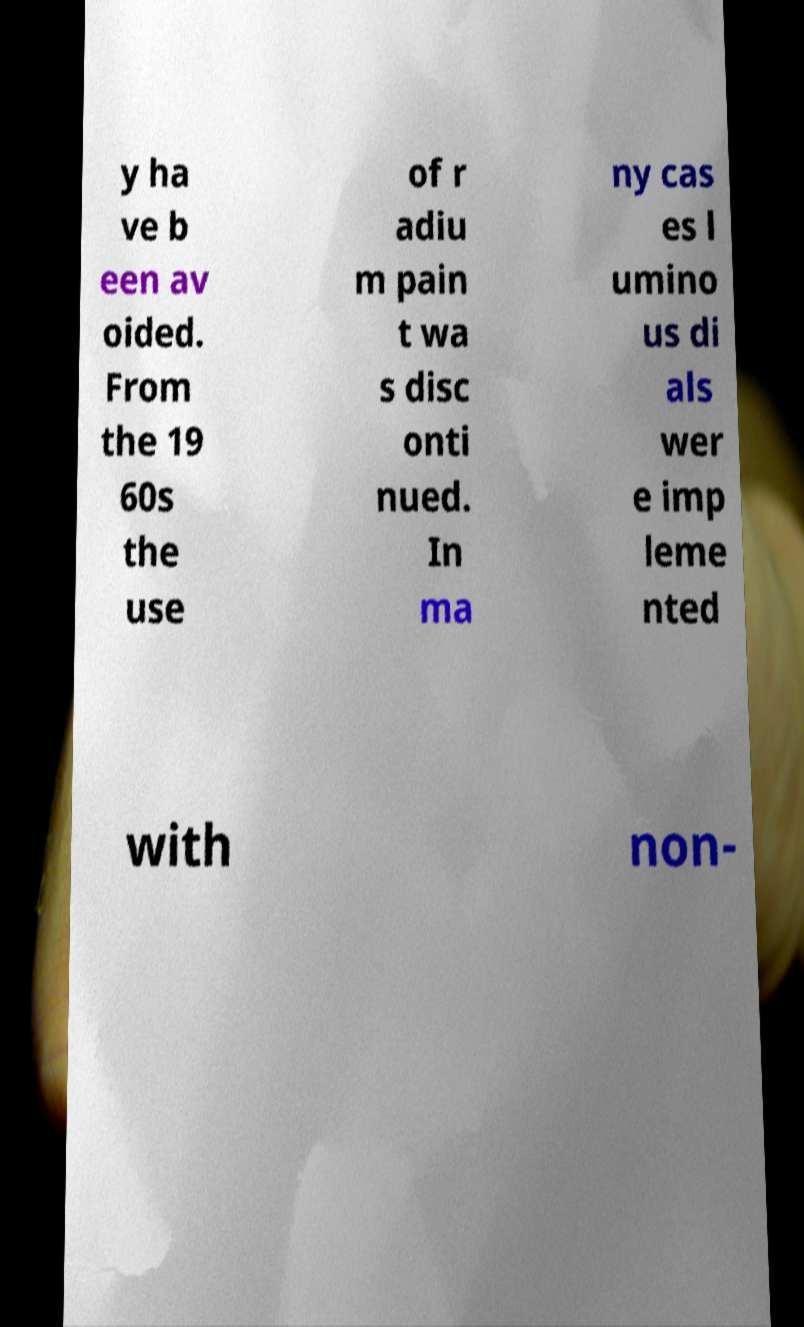Please read and relay the text visible in this image. What does it say? y ha ve b een av oided. From the 19 60s the use of r adiu m pain t wa s disc onti nued. In ma ny cas es l umino us di als wer e imp leme nted with non- 